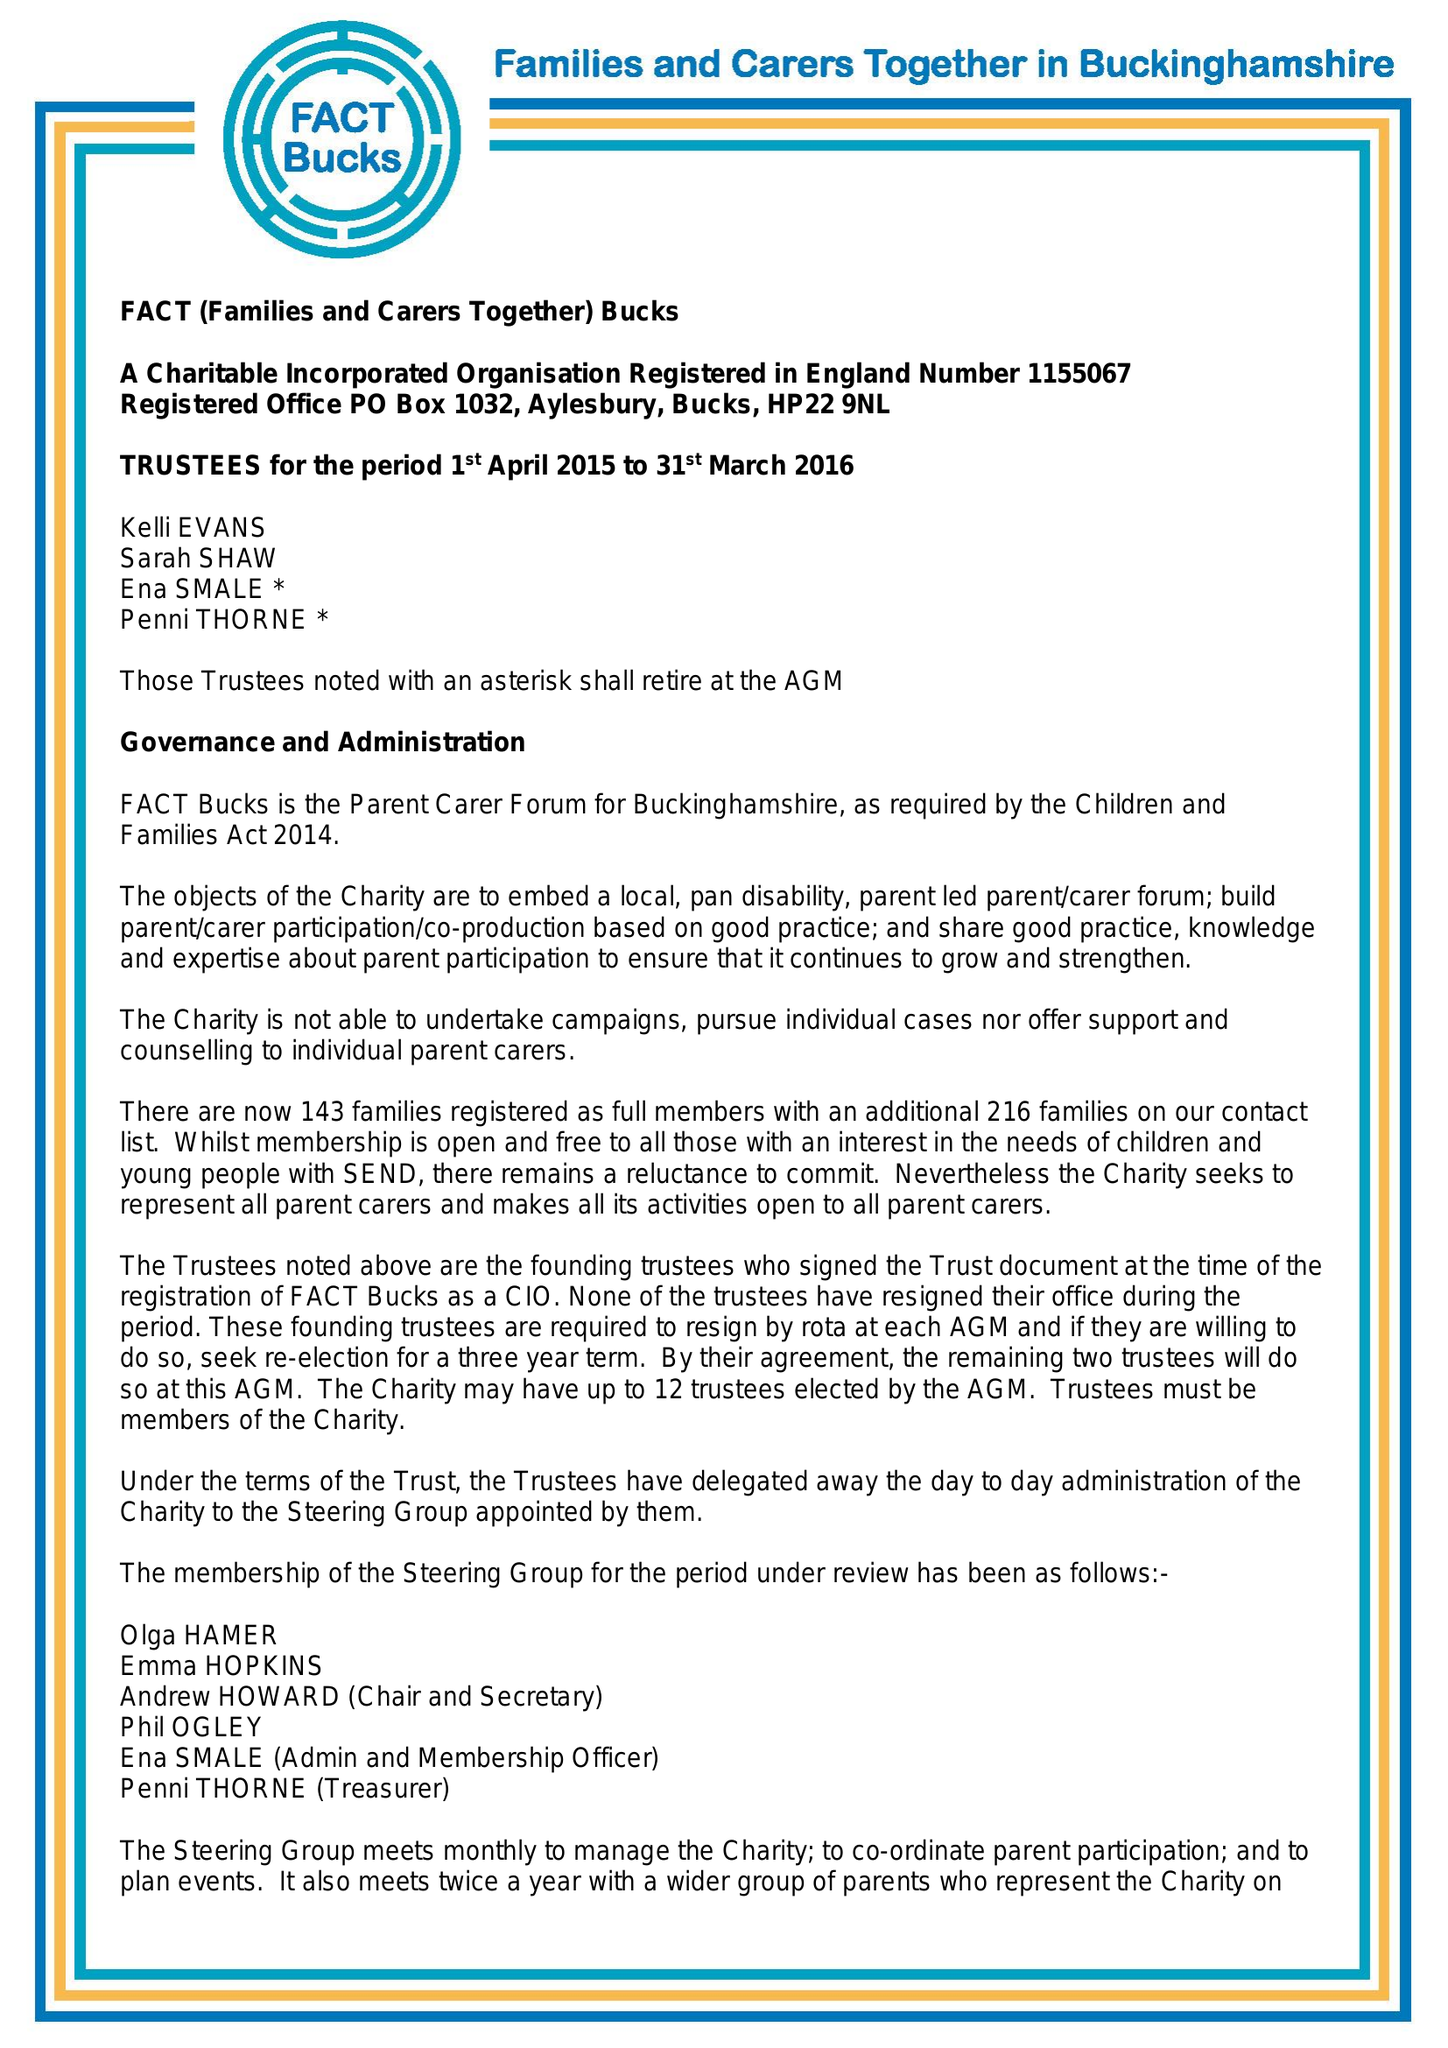What is the value for the spending_annually_in_british_pounds?
Answer the question using a single word or phrase. 25352.00 